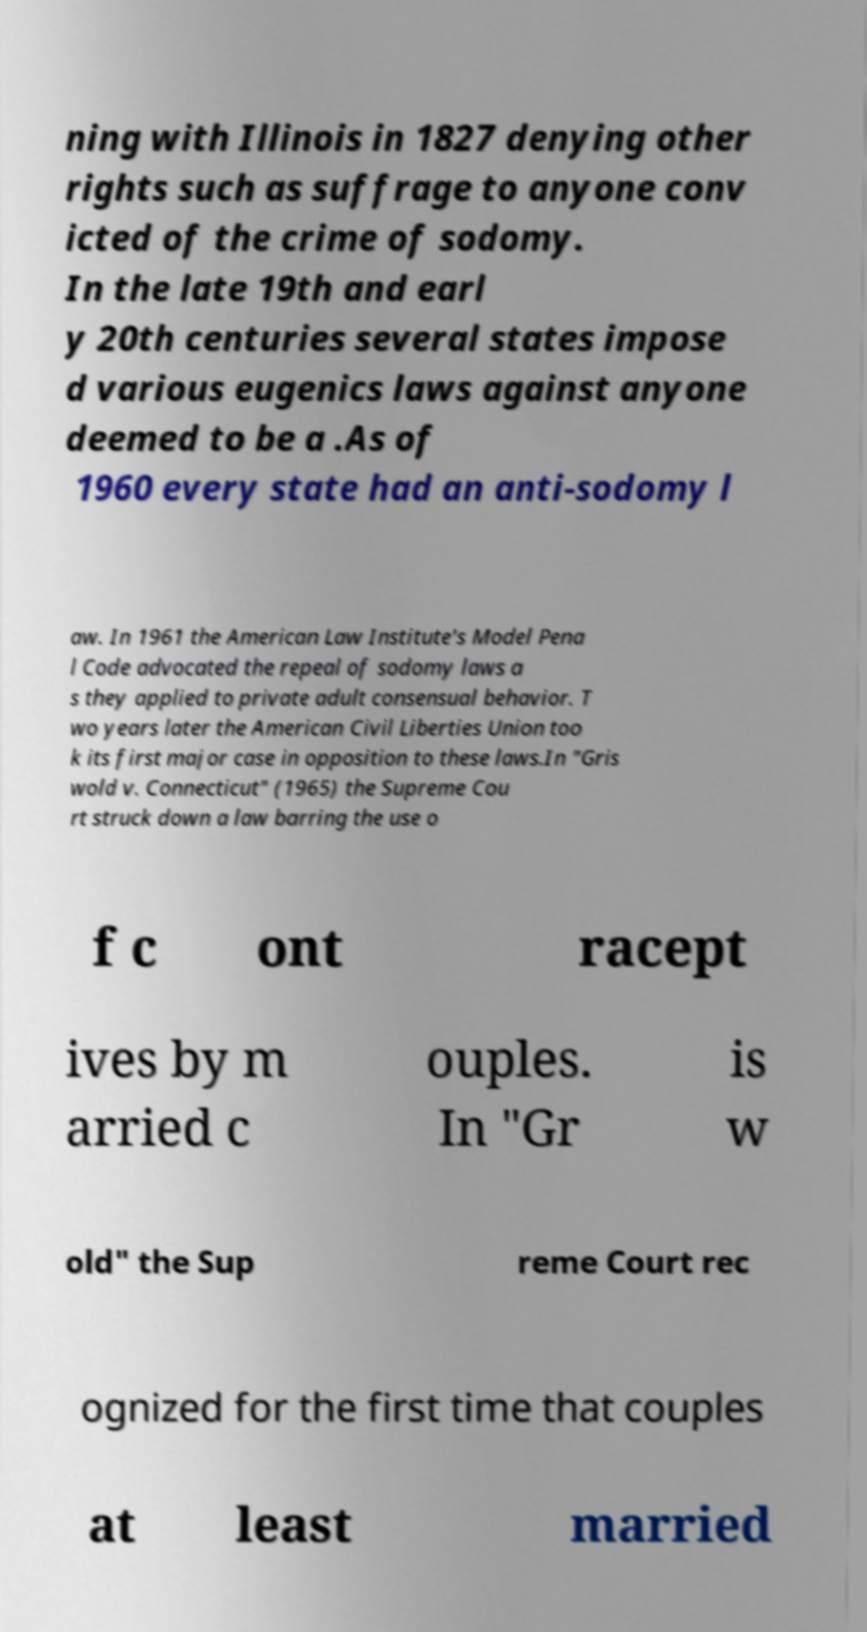Could you extract and type out the text from this image? ning with Illinois in 1827 denying other rights such as suffrage to anyone conv icted of the crime of sodomy. In the late 19th and earl y 20th centuries several states impose d various eugenics laws against anyone deemed to be a .As of 1960 every state had an anti-sodomy l aw. In 1961 the American Law Institute's Model Pena l Code advocated the repeal of sodomy laws a s they applied to private adult consensual behavior. T wo years later the American Civil Liberties Union too k its first major case in opposition to these laws.In "Gris wold v. Connecticut" (1965) the Supreme Cou rt struck down a law barring the use o f c ont racept ives by m arried c ouples. In "Gr is w old" the Sup reme Court rec ognized for the first time that couples at least married 